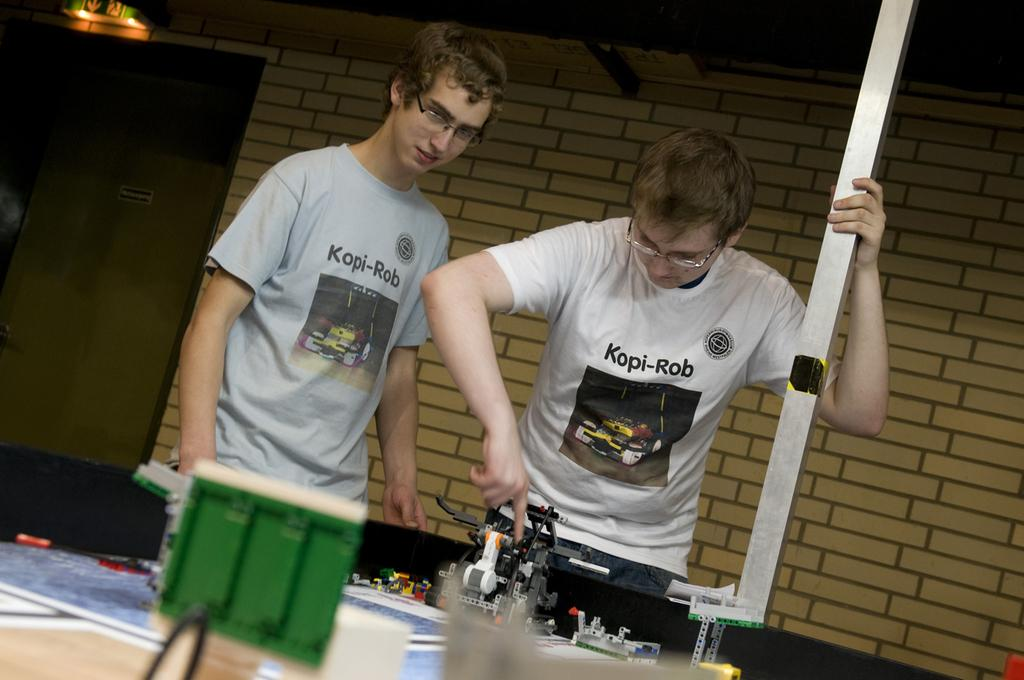How many people are in the image? There are two persons standing in the image. What is one of the persons holding? One of the persons is holding a pole. What can be seen in the background of the image? There is a wall visible in the background of the image. How many cows are visible in the image? There are no cows present in the image. Where is the faucet located in the image? There is no faucet present in the image. 